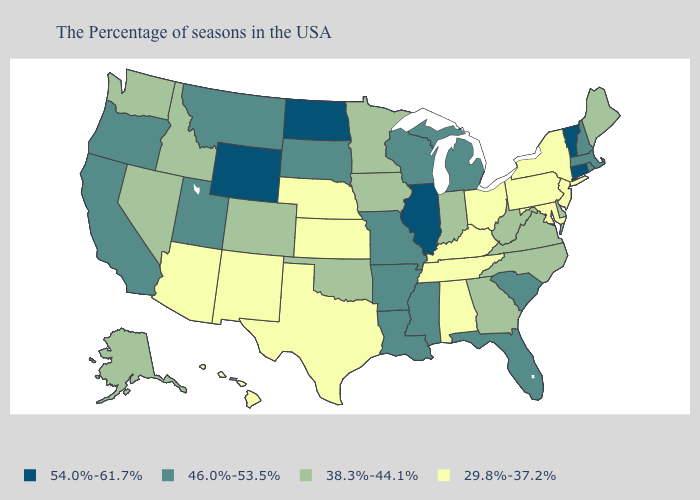Among the states that border North Carolina , does South Carolina have the lowest value?
Concise answer only. No. What is the value of Idaho?
Give a very brief answer. 38.3%-44.1%. Among the states that border Virginia , which have the highest value?
Answer briefly. North Carolina, West Virginia. Does Illinois have the highest value in the USA?
Give a very brief answer. Yes. Which states have the lowest value in the USA?
Answer briefly. New York, New Jersey, Maryland, Pennsylvania, Ohio, Kentucky, Alabama, Tennessee, Kansas, Nebraska, Texas, New Mexico, Arizona, Hawaii. What is the value of Louisiana?
Quick response, please. 46.0%-53.5%. What is the lowest value in the MidWest?
Keep it brief. 29.8%-37.2%. Among the states that border Utah , which have the highest value?
Quick response, please. Wyoming. What is the value of Massachusetts?
Quick response, please. 46.0%-53.5%. Name the states that have a value in the range 54.0%-61.7%?
Be succinct. Vermont, Connecticut, Illinois, North Dakota, Wyoming. Does the map have missing data?
Keep it brief. No. What is the value of Ohio?
Give a very brief answer. 29.8%-37.2%. How many symbols are there in the legend?
Write a very short answer. 4. What is the value of Hawaii?
Answer briefly. 29.8%-37.2%. How many symbols are there in the legend?
Concise answer only. 4. 